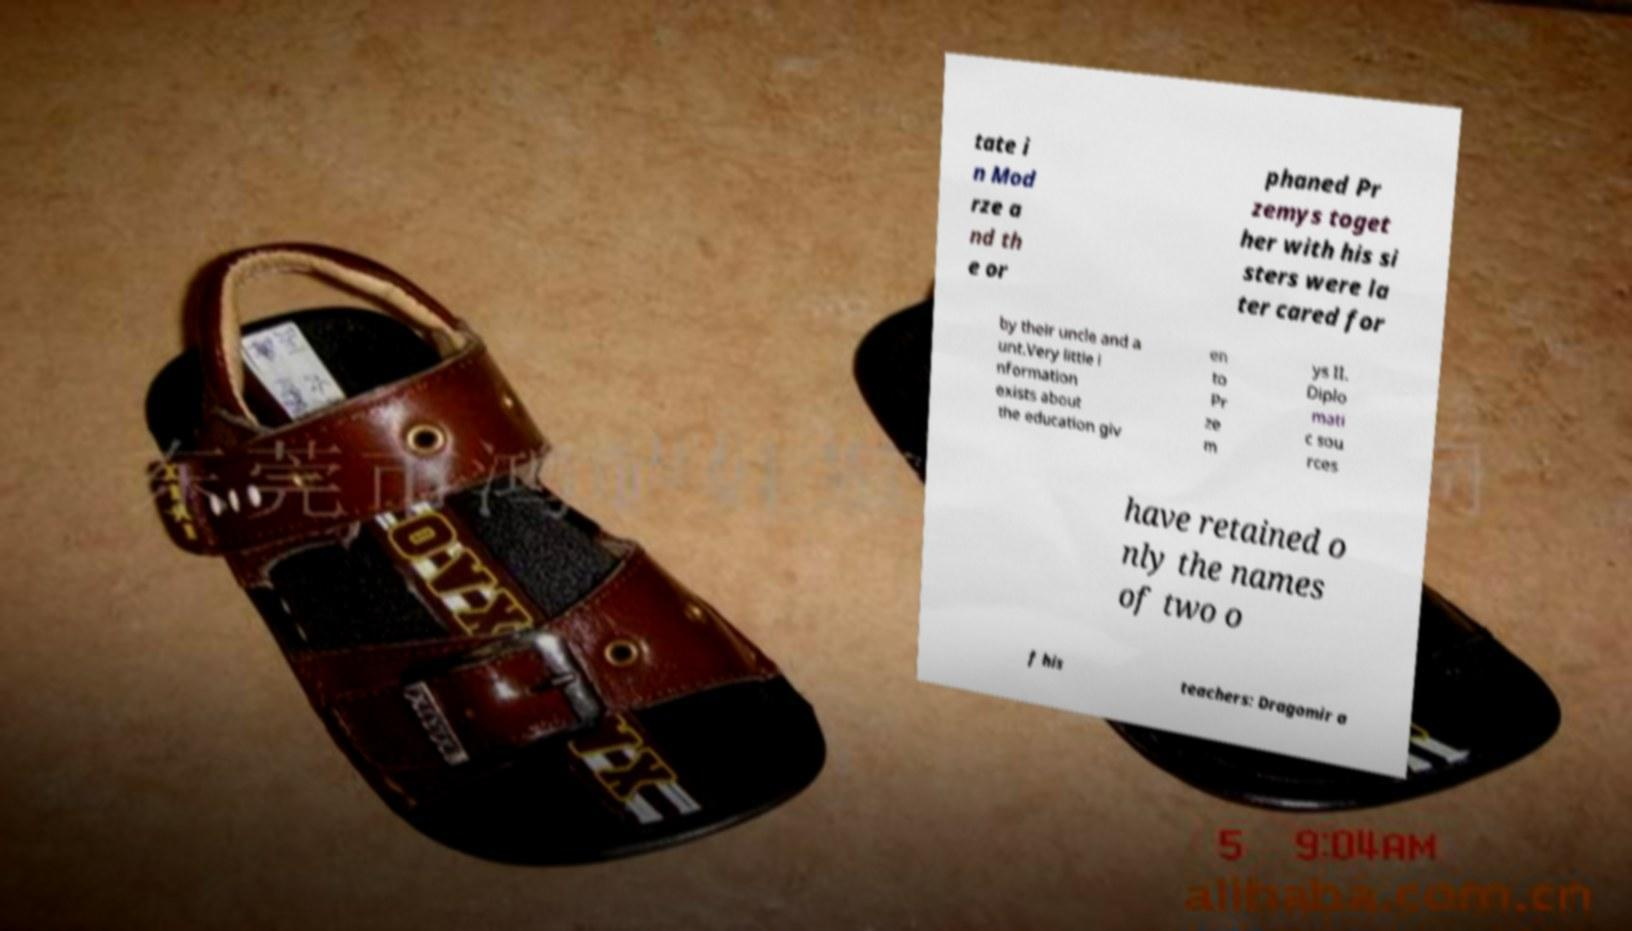What messages or text are displayed in this image? I need them in a readable, typed format. tate i n Mod rze a nd th e or phaned Pr zemys toget her with his si sters were la ter cared for by their uncle and a unt.Very little i nformation exists about the education giv en to Pr ze m ys II. Diplo mati c sou rces have retained o nly the names of two o f his teachers: Dragomir a 